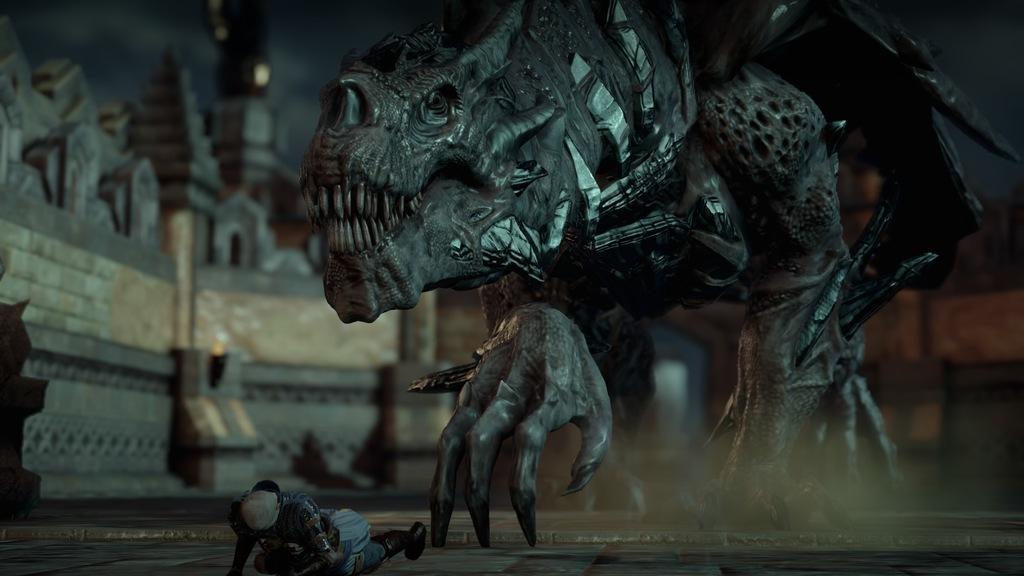In one or two sentences, can you explain what this image depicts? In this image I can see an animal in-front of the person. An animal is in ash and black color. I can see the person on the road. To the side there is a building and there is a blurred background. 